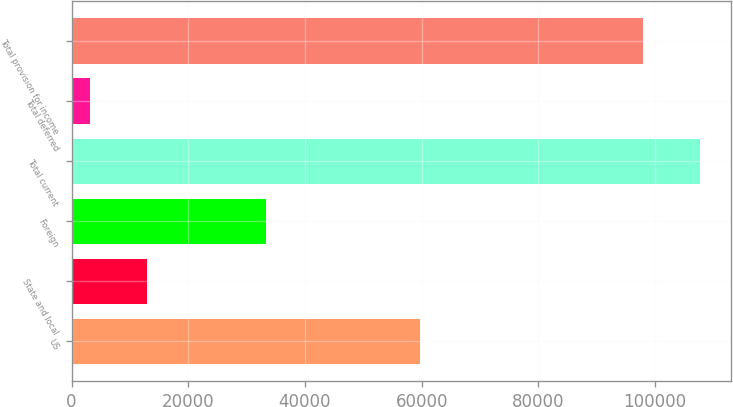Convert chart. <chart><loc_0><loc_0><loc_500><loc_500><bar_chart><fcel>US<fcel>State and local<fcel>Foreign<fcel>Total current<fcel>Total deferred<fcel>Total provision for income<nl><fcel>59707<fcel>12947.4<fcel>33240<fcel>107705<fcel>3156<fcel>97914<nl></chart> 